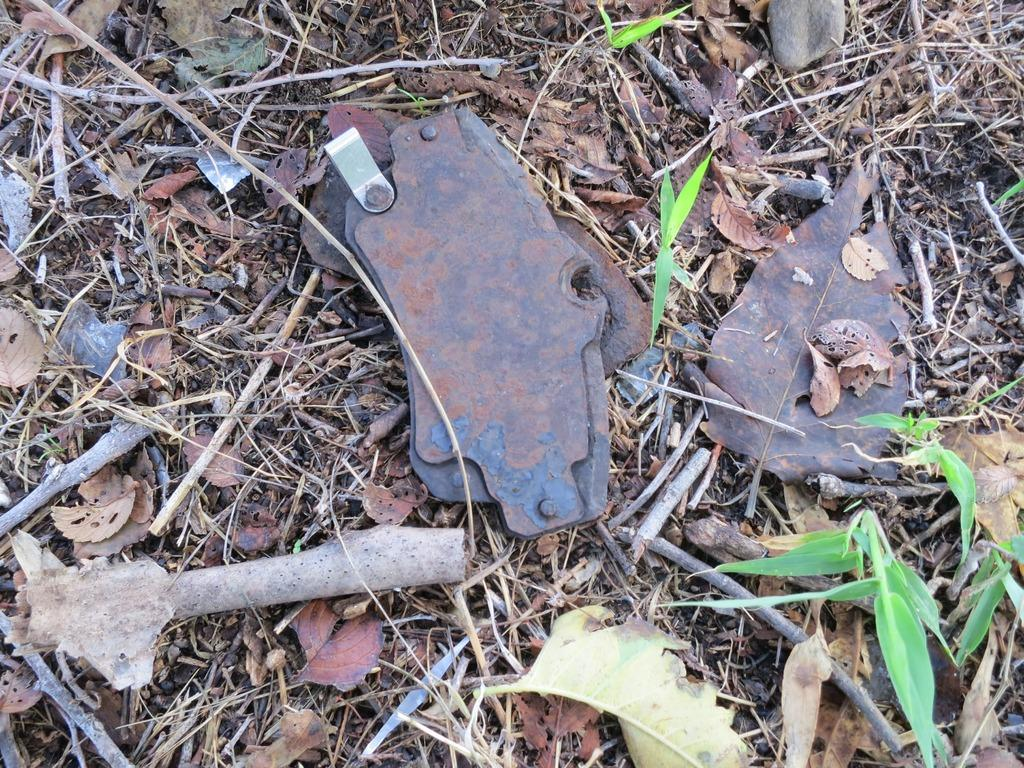What type of natural elements can be seen in the image? There are leaves in the image. Can you describe the condition of the leaves? The leaves in the image are dry. What other objects are present in the image besides the leaves? There are small wooden sticks and a metal object in the image. How does the seed in the image rub against the wooden sticks? There is no seed present in the image, so it cannot rub against the wooden sticks. 